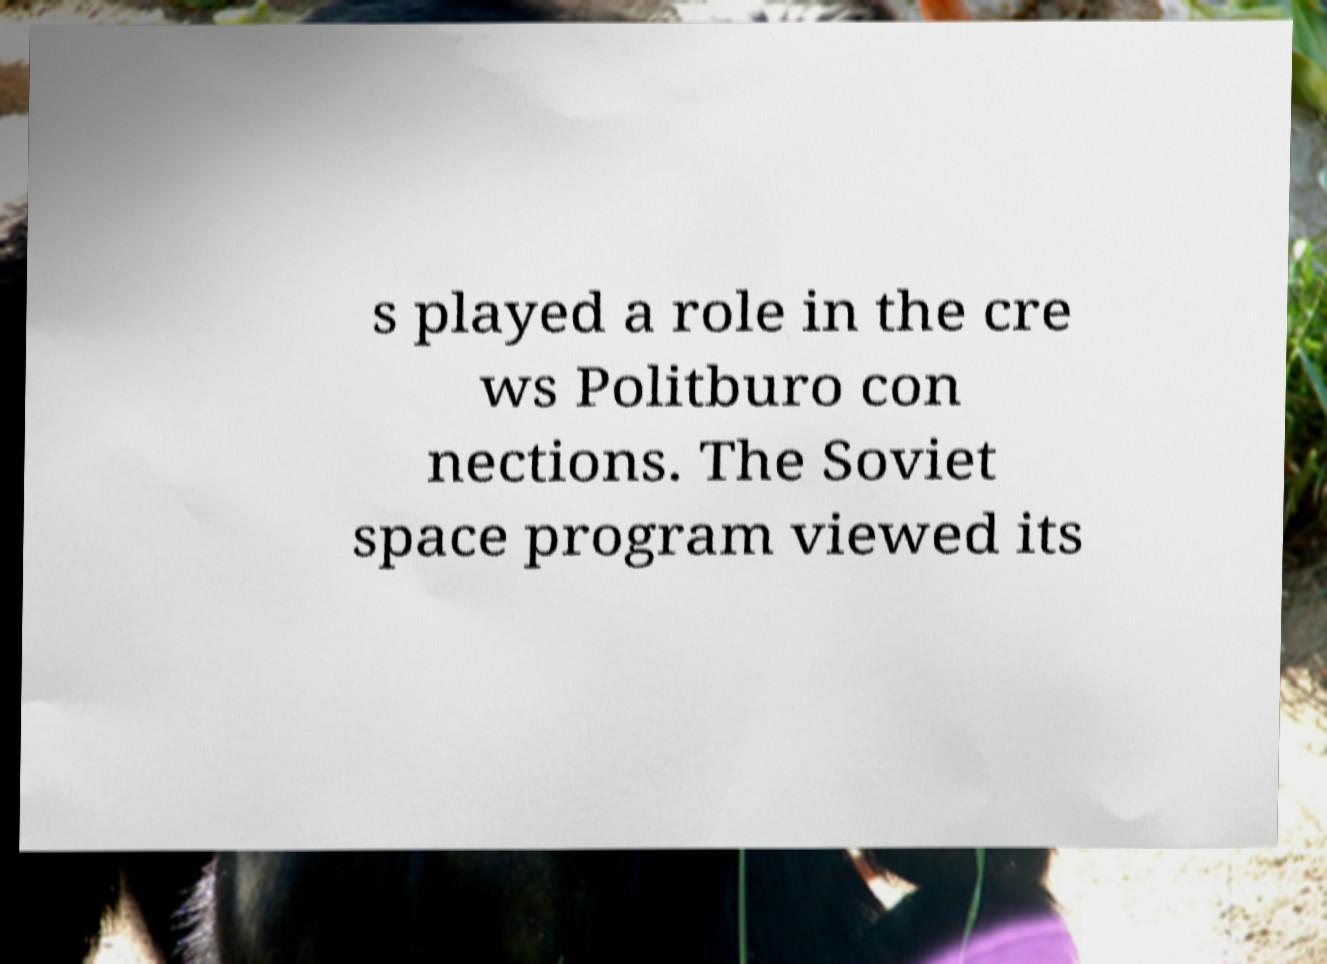Please identify and transcribe the text found in this image. s played a role in the cre ws Politburo con nections. The Soviet space program viewed its 